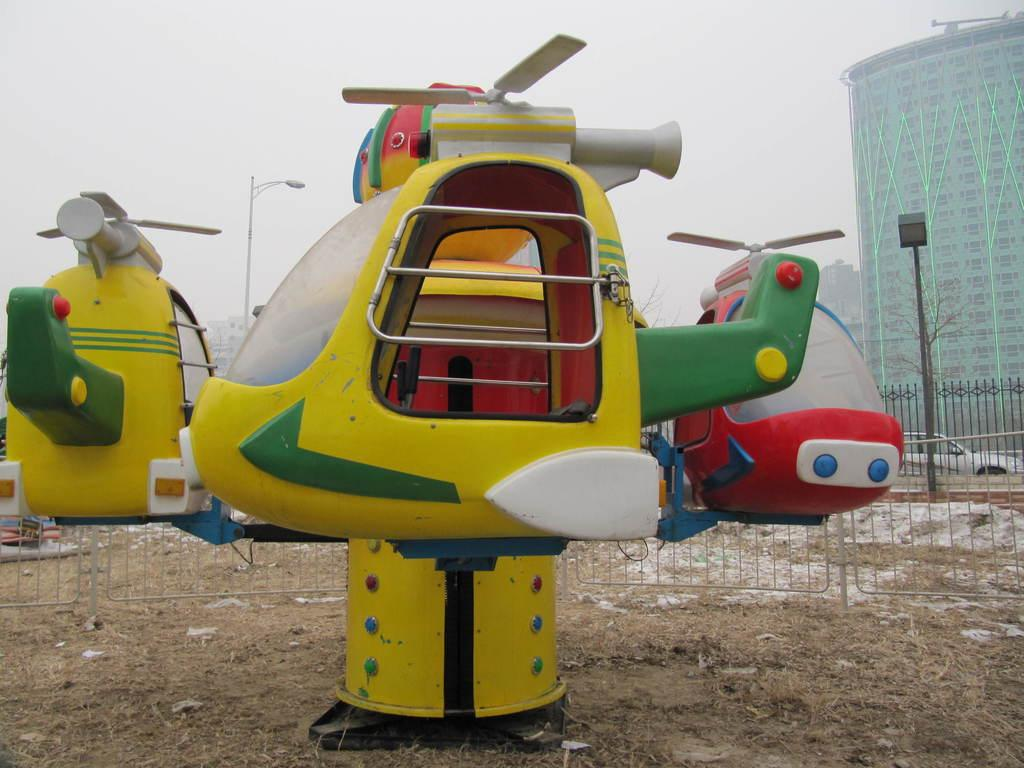What type of objects are on the ground in the image? There are toy vehicles on the ground. What kind of barrier is present in the image? There is a fence in the image. What structures are visible in the image that are used for transmitting electricity? Electric poles are visible in the image. What type of vehicle can be seen in the image? There is a vehicle in the image. What type of man-made structures are visible in the image? There are buildings in the image. What part of the natural environment is visible in the background of the image? The sky is visible in the background of the image. How many dimes are scattered on the ground in the image? There are no dimes present in the image; it features toy vehicles on the ground. What type of pencil can be seen being used by the driver of the vehicle in the image? There is no pencil visible in the image, nor is there a driver present in the vehicle. 